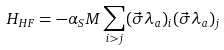Convert formula to latex. <formula><loc_0><loc_0><loc_500><loc_500>H _ { H F } = - \alpha _ { S } M \sum _ { i > j } ( \vec { \sigma } \lambda _ { a } ) _ { i } ( \vec { \sigma } \lambda _ { a } ) _ { j }</formula> 